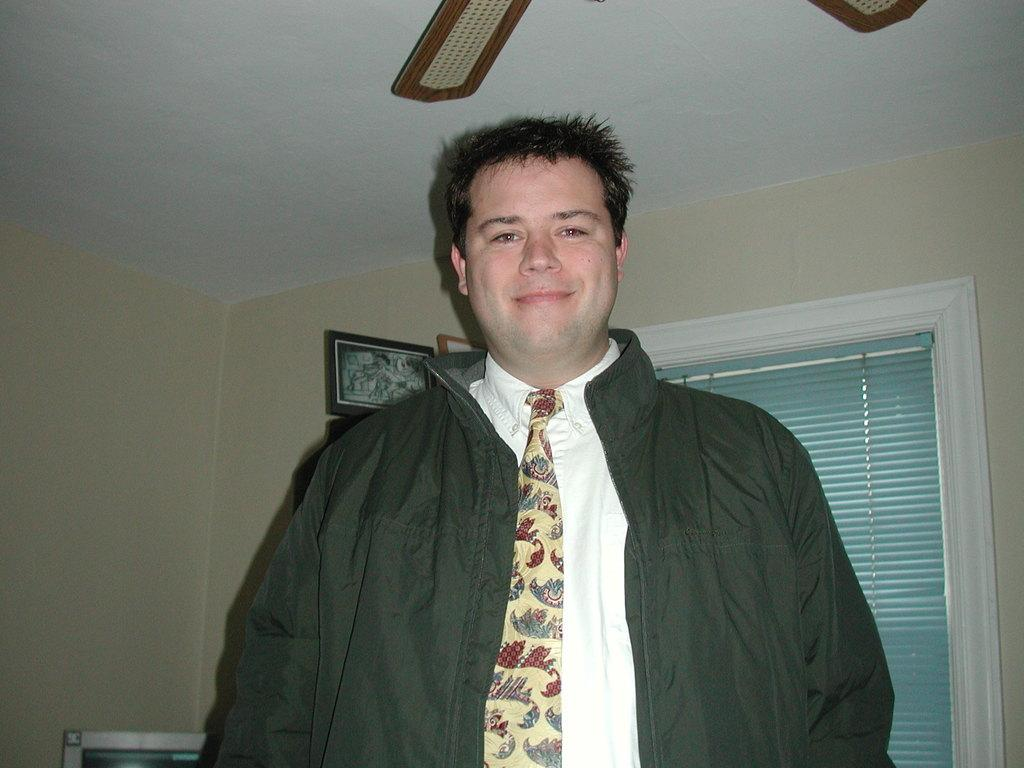Who is present in the image? There is a man in the image. What is the man wearing? The man is wearing a jacket and a tie. What is the man's facial expression? The man is smiling. What can be seen in the background of the image? There are frames on the wall, a curtain, the ceiling, and other objects visible in the background. What type of music is the man playing in the image? There is no indication in the image that the man is playing music, so it cannot be determined from the picture. 